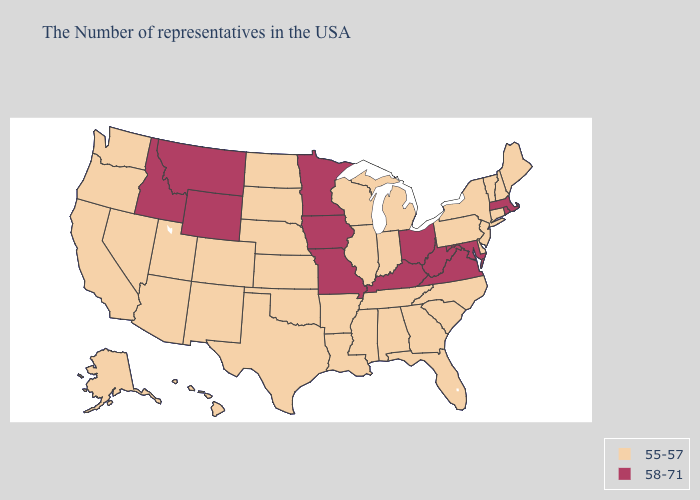Which states have the lowest value in the USA?
Give a very brief answer. Maine, New Hampshire, Vermont, Connecticut, New York, New Jersey, Delaware, Pennsylvania, North Carolina, South Carolina, Florida, Georgia, Michigan, Indiana, Alabama, Tennessee, Wisconsin, Illinois, Mississippi, Louisiana, Arkansas, Kansas, Nebraska, Oklahoma, Texas, South Dakota, North Dakota, Colorado, New Mexico, Utah, Arizona, Nevada, California, Washington, Oregon, Alaska, Hawaii. Name the states that have a value in the range 58-71?
Concise answer only. Massachusetts, Rhode Island, Maryland, Virginia, West Virginia, Ohio, Kentucky, Missouri, Minnesota, Iowa, Wyoming, Montana, Idaho. Does the map have missing data?
Keep it brief. No. Does Alaska have a lower value than Hawaii?
Give a very brief answer. No. What is the value of Indiana?
Short answer required. 55-57. Name the states that have a value in the range 58-71?
Short answer required. Massachusetts, Rhode Island, Maryland, Virginia, West Virginia, Ohio, Kentucky, Missouri, Minnesota, Iowa, Wyoming, Montana, Idaho. Does Kentucky have a higher value than Maine?
Concise answer only. Yes. Name the states that have a value in the range 55-57?
Quick response, please. Maine, New Hampshire, Vermont, Connecticut, New York, New Jersey, Delaware, Pennsylvania, North Carolina, South Carolina, Florida, Georgia, Michigan, Indiana, Alabama, Tennessee, Wisconsin, Illinois, Mississippi, Louisiana, Arkansas, Kansas, Nebraska, Oklahoma, Texas, South Dakota, North Dakota, Colorado, New Mexico, Utah, Arizona, Nevada, California, Washington, Oregon, Alaska, Hawaii. What is the highest value in the USA?
Quick response, please. 58-71. Which states have the lowest value in the USA?
Concise answer only. Maine, New Hampshire, Vermont, Connecticut, New York, New Jersey, Delaware, Pennsylvania, North Carolina, South Carolina, Florida, Georgia, Michigan, Indiana, Alabama, Tennessee, Wisconsin, Illinois, Mississippi, Louisiana, Arkansas, Kansas, Nebraska, Oklahoma, Texas, South Dakota, North Dakota, Colorado, New Mexico, Utah, Arizona, Nevada, California, Washington, Oregon, Alaska, Hawaii. What is the value of Illinois?
Keep it brief. 55-57. Which states have the highest value in the USA?
Concise answer only. Massachusetts, Rhode Island, Maryland, Virginia, West Virginia, Ohio, Kentucky, Missouri, Minnesota, Iowa, Wyoming, Montana, Idaho. Does Connecticut have a higher value than Kentucky?
Short answer required. No. What is the value of California?
Concise answer only. 55-57. What is the value of Alabama?
Be succinct. 55-57. 